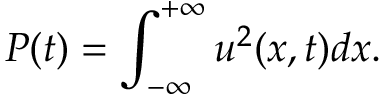Convert formula to latex. <formula><loc_0><loc_0><loc_500><loc_500>P ( t ) = \int _ { - \infty } ^ { + \infty } u ^ { 2 } ( x , t ) d x .</formula> 